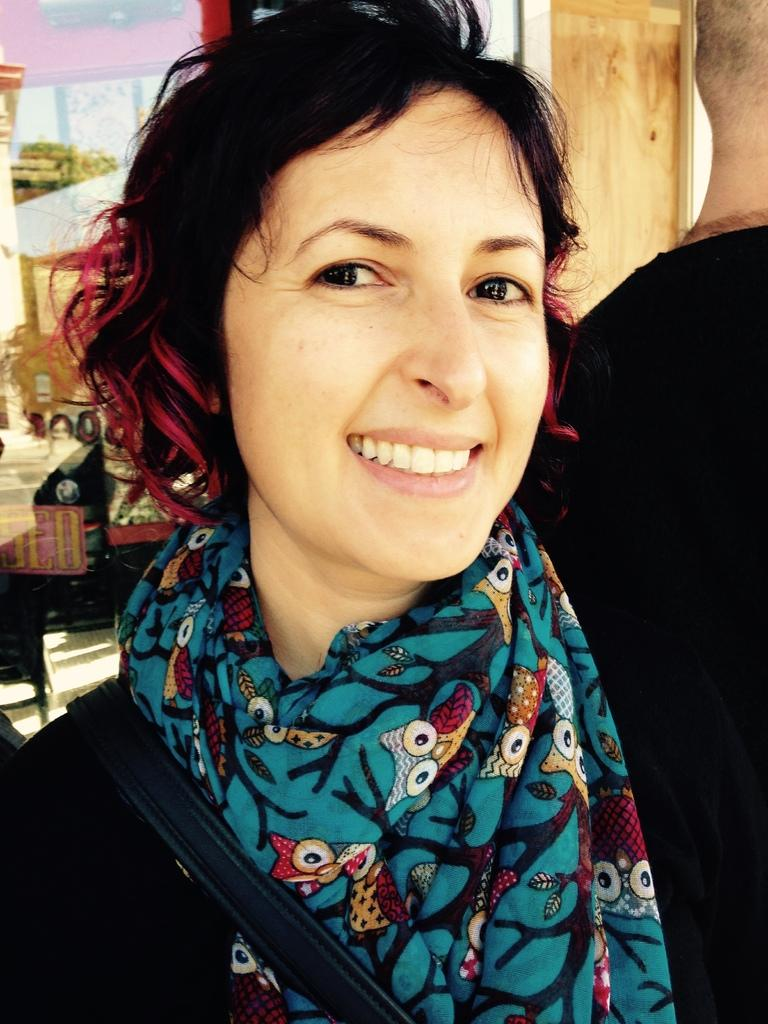Who is present in the image? There is a woman in the image. What is the woman doing in the image? The woman is standing in the image. What is the woman's facial expression in the image? The woman is smiling in the image. What accessory can be seen in the image? There is a scarf in the image. What is the woman wearing in the image? The woman is wearing a black dress in the image. What type of trucks can be seen in the background of the image? There are no trucks visible in the image. 